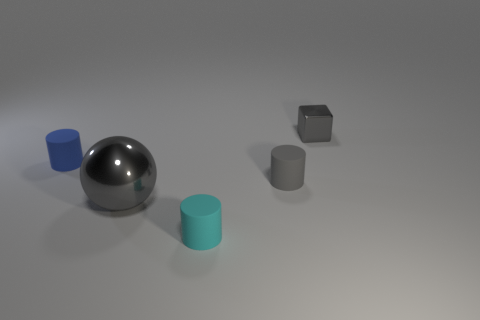Subtract all small cyan cylinders. How many cylinders are left? 2 Subtract all cyan cylinders. How many cylinders are left? 2 Subtract all cylinders. How many objects are left? 2 Add 3 small rubber cylinders. How many small rubber cylinders are left? 6 Add 5 large purple cylinders. How many large purple cylinders exist? 5 Add 3 small cyan objects. How many objects exist? 8 Subtract 0 green spheres. How many objects are left? 5 Subtract 3 cylinders. How many cylinders are left? 0 Subtract all green cylinders. Subtract all gray spheres. How many cylinders are left? 3 Subtract all brown balls. How many cyan cylinders are left? 1 